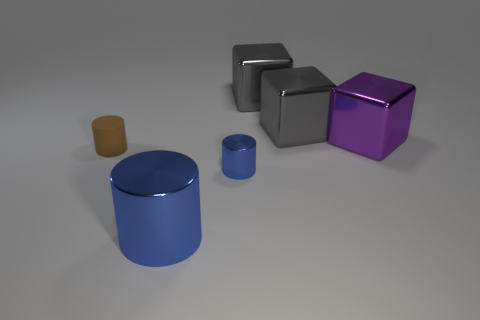Is the size of the purple metallic object right of the brown cylinder the same as the large blue cylinder?
Make the answer very short. Yes. Is the number of objects less than the number of large brown rubber things?
Your answer should be very brief. No. What shape is the small thing that is the same color as the big metallic cylinder?
Offer a terse response. Cylinder. How many large gray cubes are on the left side of the large purple cube?
Ensure brevity in your answer.  2. Do the small blue object and the purple metallic object have the same shape?
Offer a very short reply. No. How many metal things are both left of the tiny blue thing and behind the small brown matte cylinder?
Provide a succinct answer. 0. What number of objects are either large purple metallic things or objects behind the large blue shiny object?
Your response must be concise. 5. Is the number of big things greater than the number of tiny blue metal cylinders?
Keep it short and to the point. Yes. What shape is the large metal thing in front of the large purple shiny object?
Offer a very short reply. Cylinder. What number of tiny blue things are the same shape as the brown matte object?
Your response must be concise. 1. 